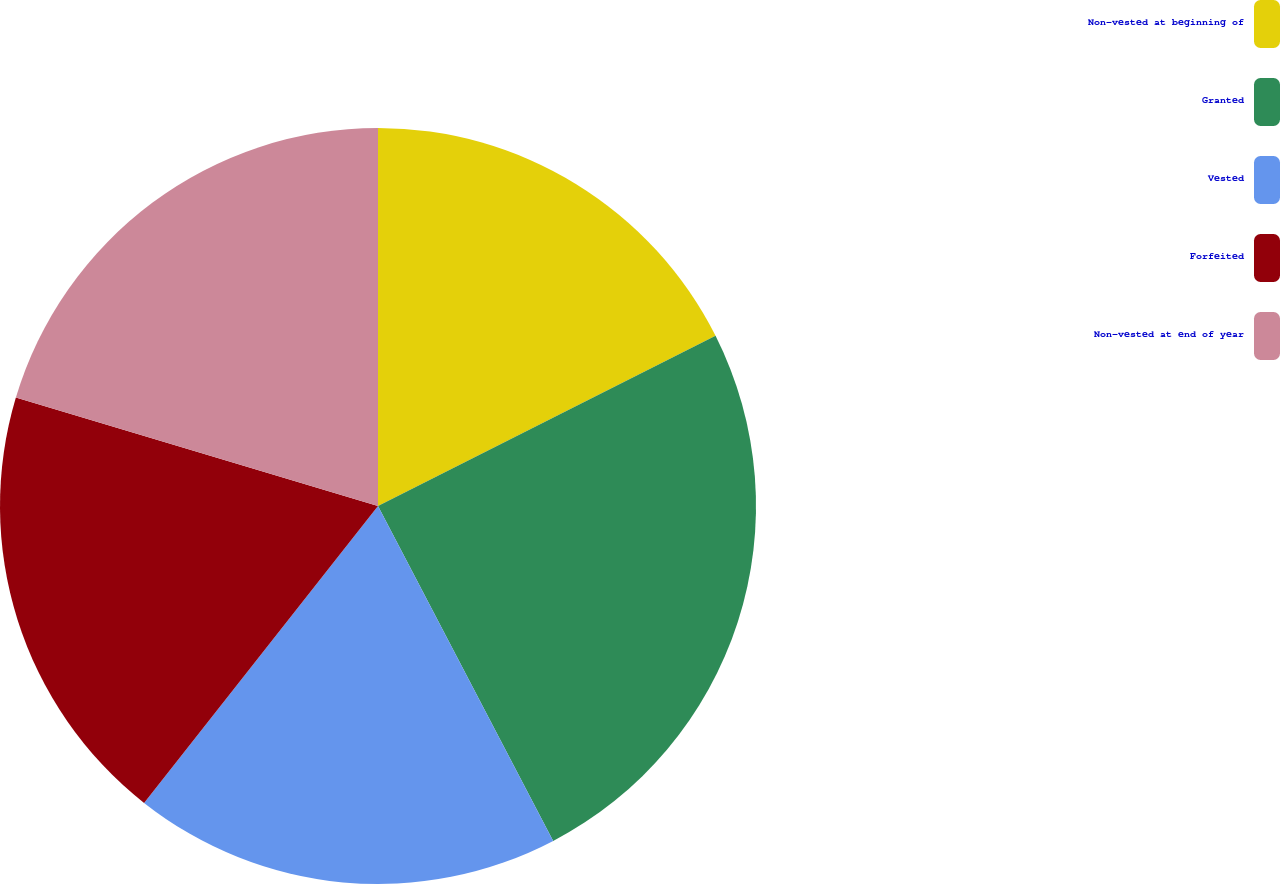<chart> <loc_0><loc_0><loc_500><loc_500><pie_chart><fcel>Non-vested at beginning of<fcel>Granted<fcel>Vested<fcel>Forfeited<fcel>Non-vested at end of year<nl><fcel>17.57%<fcel>24.76%<fcel>18.29%<fcel>19.01%<fcel>20.37%<nl></chart> 